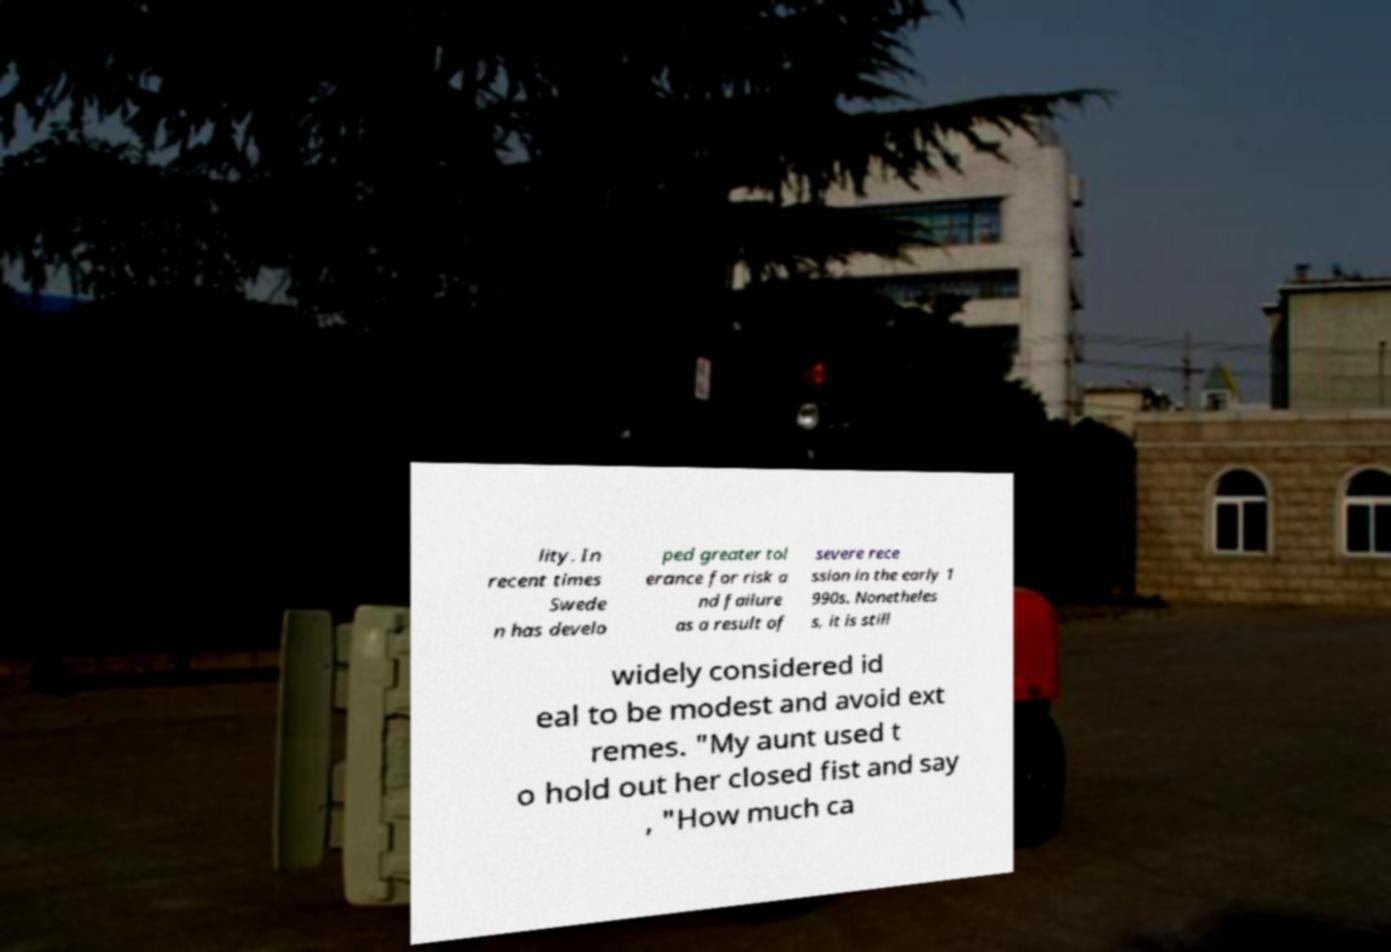Could you assist in decoding the text presented in this image and type it out clearly? lity. In recent times Swede n has develo ped greater tol erance for risk a nd failure as a result of severe rece ssion in the early 1 990s. Nonetheles s, it is still widely considered id eal to be modest and avoid ext remes. "My aunt used t o hold out her closed fist and say , "How much ca 